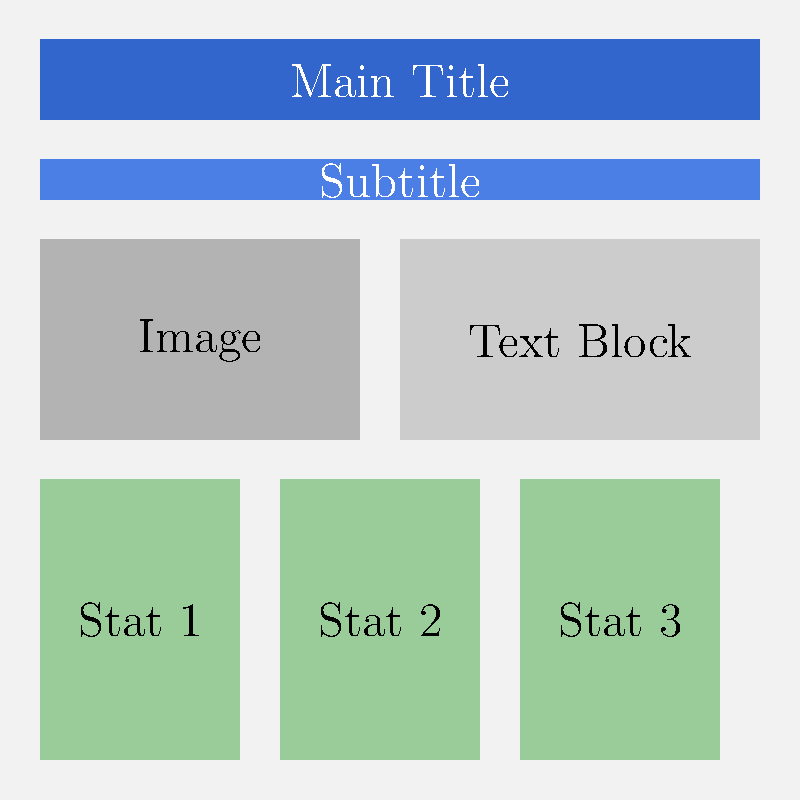As a communications specialist, analyze the visual hierarchy of elements in this marketing infographic. Which element is likely to draw the viewer's attention first, and why? To analyze the visual hierarchy of elements in this marketing infographic, we need to consider several factors:

1. Size: Larger elements tend to draw more attention.
2. Color: Brighter or contrasting colors stand out more.
3. Position: Elements at the top or in the center are often noticed first.
4. White space: Elements with more surrounding space can be more prominent.

Let's examine each element:

1. Main Title: 
   - Large size
   - Dark blue color (high contrast with the background)
   - Top position
   - Spans the full width of the infographic

2. Subtitle:
   - Slightly smaller than the main title
   - Lighter blue color
   - Just below the main title

3. Image:
   - Medium size
   - Gray color (low contrast)
   - Left side of the middle section

4. Text Block:
   - Medium size
   - Light gray color (low contrast)
   - Right side of the middle section

5. Statistics (Stat 1, Stat 2, Stat 3):
   - Smaller size
   - Light green color (moderate contrast)
   - Bottom of the infographic

Based on these factors, the Main Title is likely to draw the viewer's attention first because:
1. It has the largest size among all elements.
2. It uses a dark blue color that contrasts strongly with the light background.
3. It is positioned at the top of the infographic, where readers naturally start.
4. It spans the full width, making it impossible to miss.

These characteristics combined make the Main Title the most visually prominent element in the hierarchy of this infographic.
Answer: Main Title, due to its large size, high contrast color, and top position. 